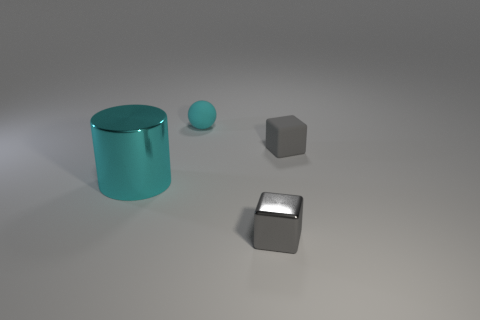There is a gray cube on the left side of the small gray thing behind the metal cube; what size is it?
Offer a very short reply. Small. What is the size of the thing that is made of the same material as the cylinder?
Your response must be concise. Small. There is a thing that is in front of the gray matte thing and right of the large cyan cylinder; what shape is it?
Ensure brevity in your answer.  Cube. Is the number of small gray rubber blocks right of the small gray rubber cube the same as the number of large blue metallic cylinders?
Provide a succinct answer. Yes. What number of objects are brown metallic things or metallic things to the left of the small matte ball?
Your answer should be compact. 1. Are there any other cyan matte objects of the same shape as the cyan matte thing?
Give a very brief answer. No. Are there the same number of small cubes behind the rubber block and small matte spheres that are to the left of the cyan sphere?
Your answer should be very brief. Yes. Are there any other things that are the same size as the cyan metal object?
Keep it short and to the point. No. What number of cyan things are tiny matte objects or shiny spheres?
Your answer should be very brief. 1. How many other rubber things are the same size as the cyan rubber object?
Keep it short and to the point. 1. 